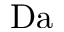Convert formula to latex. <formula><loc_0><loc_0><loc_500><loc_500>D a</formula> 